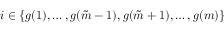<formula> <loc_0><loc_0><loc_500><loc_500>i \in \{ g ( 1 ) , \dots , g ( \tilde { m } - 1 ) , g ( \tilde { m } + 1 ) , \dots , g ( m ) \}</formula> 